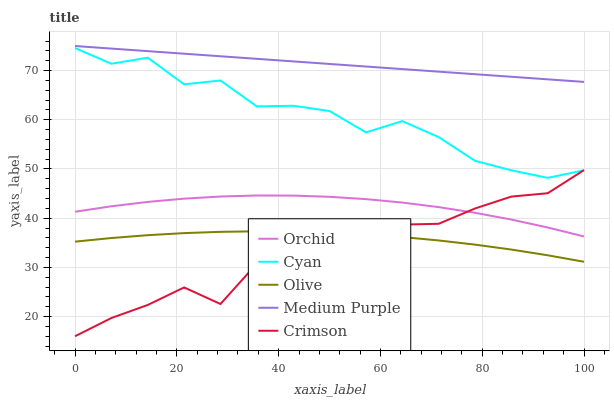Does Crimson have the minimum area under the curve?
Answer yes or no. Yes. Does Medium Purple have the maximum area under the curve?
Answer yes or no. Yes. Does Cyan have the minimum area under the curve?
Answer yes or no. No. Does Cyan have the maximum area under the curve?
Answer yes or no. No. Is Medium Purple the smoothest?
Answer yes or no. Yes. Is Cyan the roughest?
Answer yes or no. Yes. Is Cyan the smoothest?
Answer yes or no. No. Is Medium Purple the roughest?
Answer yes or no. No. Does Crimson have the lowest value?
Answer yes or no. Yes. Does Cyan have the lowest value?
Answer yes or no. No. Does Medium Purple have the highest value?
Answer yes or no. Yes. Does Cyan have the highest value?
Answer yes or no. No. Is Orchid less than Cyan?
Answer yes or no. Yes. Is Orchid greater than Olive?
Answer yes or no. Yes. Does Crimson intersect Orchid?
Answer yes or no. Yes. Is Crimson less than Orchid?
Answer yes or no. No. Is Crimson greater than Orchid?
Answer yes or no. No. Does Orchid intersect Cyan?
Answer yes or no. No. 